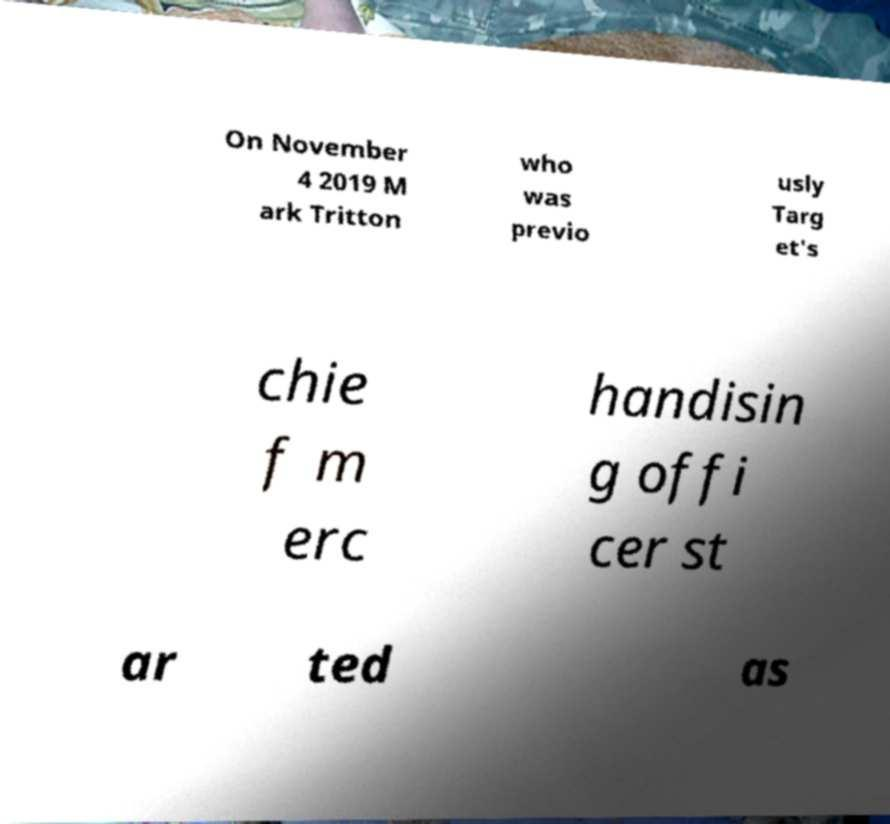Could you assist in decoding the text presented in this image and type it out clearly? On November 4 2019 M ark Tritton who was previo usly Targ et's chie f m erc handisin g offi cer st ar ted as 